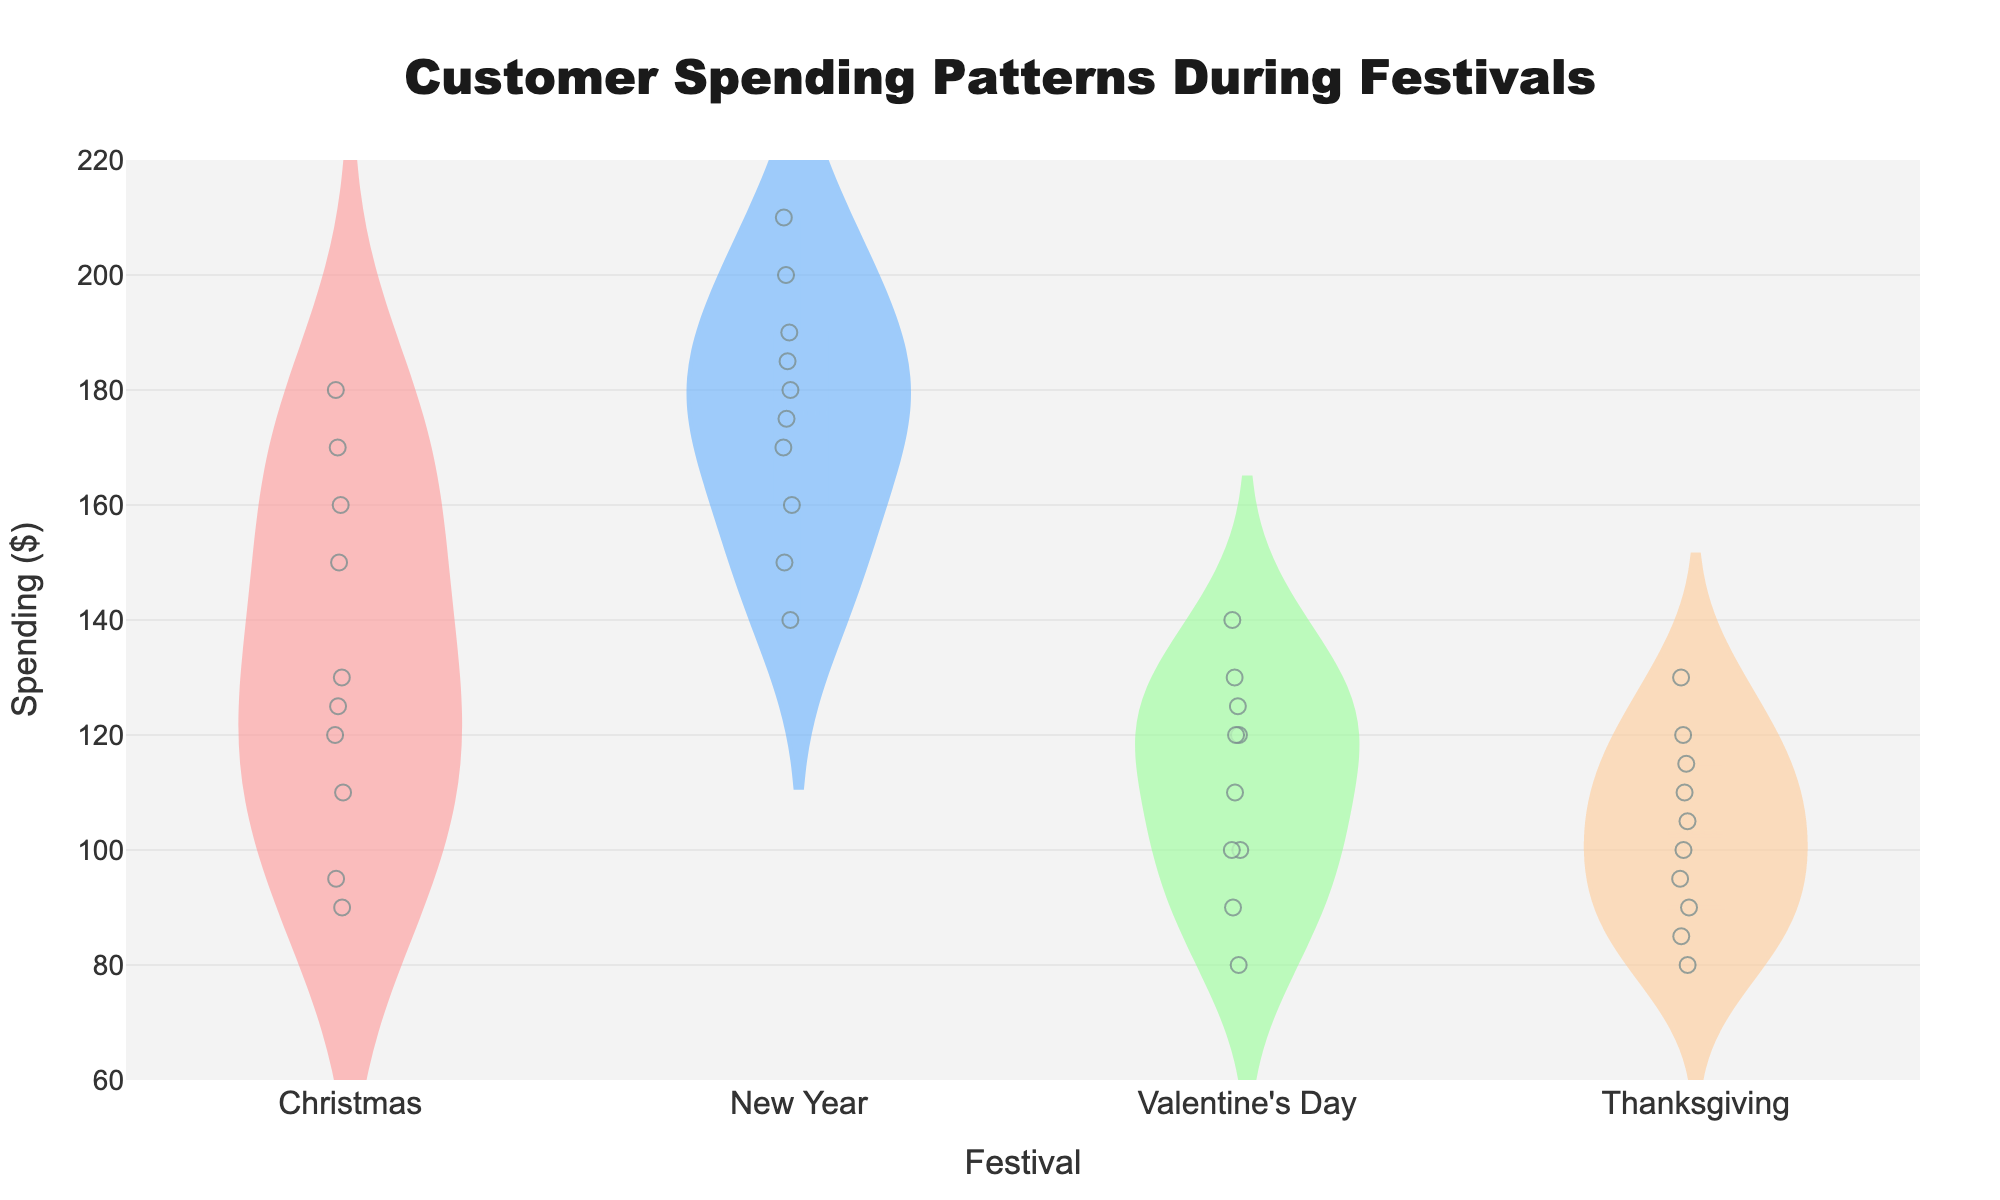What festival has the highest average customer spending? The New Year festival shows a higher central tendency in its distribution. The average, often indicated by the mean line in a violin plot, appears highest for New Year compared to other festivals.
Answer: New Year What is the title of the plot? The title can be found at the top of the plot, where it reads "Customer Spending Patterns During Festivals".
Answer: Customer Spending Patterns During Festivals How many data points are there for Christmas? Counting the individual data points represented by dots along the Christmas violin plot, there are 10 data points.
Answer: 10 Which festival shows the smallest spread of customer spending? By observing the width of each violin plot, Valentine's Day has the narrowest spread compared to the others, indicating less variation in spending.
Answer: Valentine's Day What is the range of spending during Thanksgiving? The minimum and maximum points in the Thanksgiving violin plot indicate the range of spending, from $80 to $130.
Answer: $80 to $130 Which festival has the lowest high-end outlier? The highest data point in each violin plot can be compared. The Christmas festival has the lowest high-end outlier of $180.
Answer: Christmas During which festival does customer spending show the largest difference from the mean? Comparing the distribution and the points, the New Year's festival shows the largest difference from the mean, with spending reaching as high as $210 and as low as $150.
Answer: New Year What is the median spending during Thanksgiving? The median is marked within the box plots inside the violins; for Thanksgiving, it is approximately $105.
Answer: $105 Is the customer spending more uniform during Christmas or Valentine's Day? Valentine's Day has a tighter distribution, indicating more uniform spending compared to the wider and more varied distribution of Christmas.
Answer: Valentine's Day Which festival has the highest spending value and what is it? Observing the peaks of each violin plot, the highest spending is during the New Year, at $210.
Answer: New Year, $210 